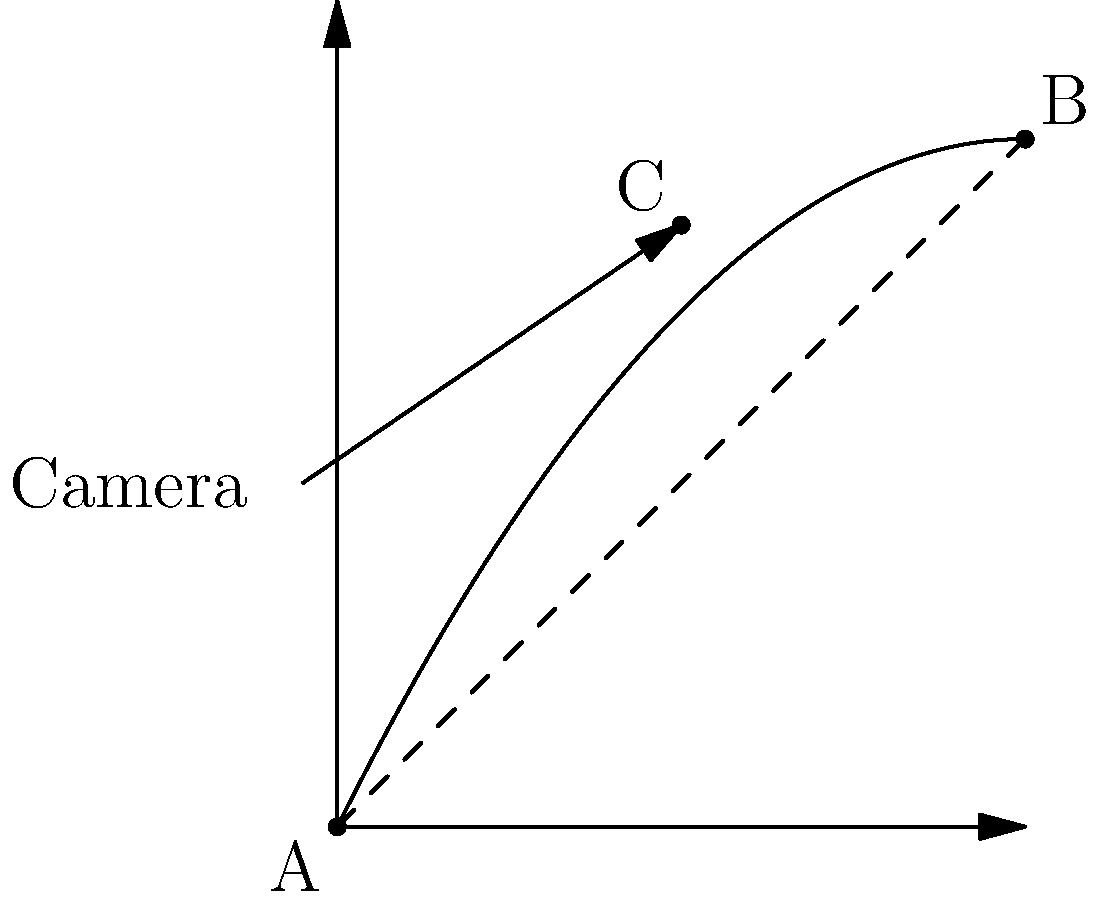In a scene depicting a projectile's trajectory, how does the camera angle from point A to point C affect the perceived motion compared to the actual path from A to B? Consider the implications for cinematography in regional films with limited special effects budgets. To understand the effect of the camera angle on the perceived motion of the projectile, let's break it down step-by-step:

1. Actual trajectory: The projectile follows a parabolic path from A to B, described by the equation $y = -0.1x^2 + 2x$.

2. Camera perspective: The camera is positioned at point A and focuses on point C, which is on the trajectory but not the endpoint.

3. Perceived motion: From the camera's perspective, the projectile appears to move along the straight line AC.

4. Comparison:
   a) The actual path (AB) is curved, while the perceived path (AC) is straight.
   b) The endpoint B is higher than the perceived endpoint C.

5. Cinematographic implications:
   a) This perspective creates an illusion of a flatter trajectory.
   b) It can make the projectile appear to move faster in the middle of its path.
   c) The true apex of the trajectory may be hidden from view.

6. Budget considerations:
   a) This camera angle can create a dramatic effect without expensive special effects.
   b) It allows filmmakers to suggest a longer range or higher trajectory than actually achieved.
   c) The discrepancy between perceived and actual motion can be used for artistic effect or to mask limitations in practical effects.

For regional filmmakers with limited budgets, this technique can be used to create visually compelling scenes without relying on costly CGI or elaborate sets. By carefully choosing camera angles, they can manipulate the audience's perception of motion and create more dynamic action sequences.
Answer: The camera angle creates an illusion of a flatter, faster trajectory, allowing for dramatic effects without costly special effects. 